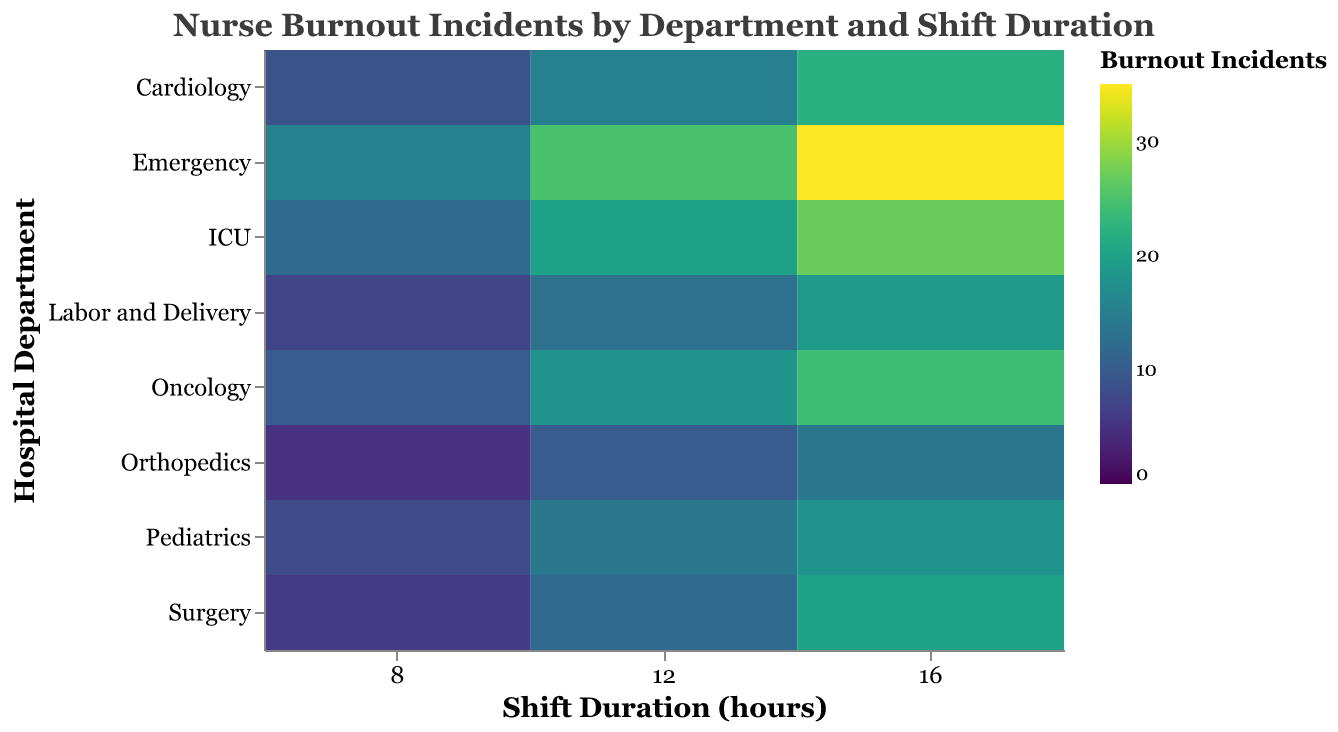What is the title of the heatmap? The title is located at the top center of the heatmap, displayed in a larger font size and different color, making it stand out. The title is "Nurse Burnout Incidents by Department and Shift Duration."
Answer: Nurse Burnout Incidents by Department and Shift Duration Which department has the highest number of burnout incidents for a 16-hour shift? Look at the color scale for the shift duration of 16 hours and identify the darkest shade (indicating the highest value). The department with the darkest shade for 16-hour shifts is Emergency, with 35 incidents.
Answer: Emergency What is the range of burnout incidents displayed on the heatmap's color scale? Check the scale bar for 'Burnout Incidents' which shows the minimum and maximum values represented in the heatmap. The scale ranges from 0 to 35 incidents.
Answer: 0 to 35 How many incidents of burnout are recorded for the Pediatrics department during an 8-hour shift? Locate the Pediatrics row and then look at the column for an 8-hour shift. The corresponding color indicates the number of incidents, which is 8.
Answer: 8 Which department has fewer burnout incidents for a 12-hour shift, Orthopedics or Cardiology? Compare the colors for Orthopedics and Cardiology at the 12-hour shift duration. Orthopedics has 10 incidents while Cardiology has 15, so Orthopedics has fewer incidents.
Answer: Orthopedics What is the difference in burnout incidents between the 8-hour shift and the 16-hour shift in the ICU department? Locate the ICU row and identify the values for the 8-hour shift (12 incidents) and the 16-hour shift (27 incidents). Subtract the smaller number from the larger number: 27 - 12 = 15.
Answer: 15 How does the burnout incident count change as shift durations increase in the Surgery department? Observe the shades of color for Surgery across the 8, 12, and 16-hour shifts. The colors gradually get darker, indicating increasing burnout incidents: 6, 12, and 20, respectively.
Answer: Increases What average number of burnout incidents is recorded across all departments for the 8-hour shift? Add all the burnout incidents for each department during the 8-hour shift and then divide by the number of departments (9). The sum is 15+12+8+10+6+9+7+5 = 72, then 72/9 = 8.
Answer: 8 Which department displays the least variability in burnout incidents across different shift durations? Check each department and note the range of their burnout incidents across the 8, 12, and 16-hour shifts. Pediatrics has incidents of 8, 14, and 18, showing the least variability.
Answer: Pediatrics 